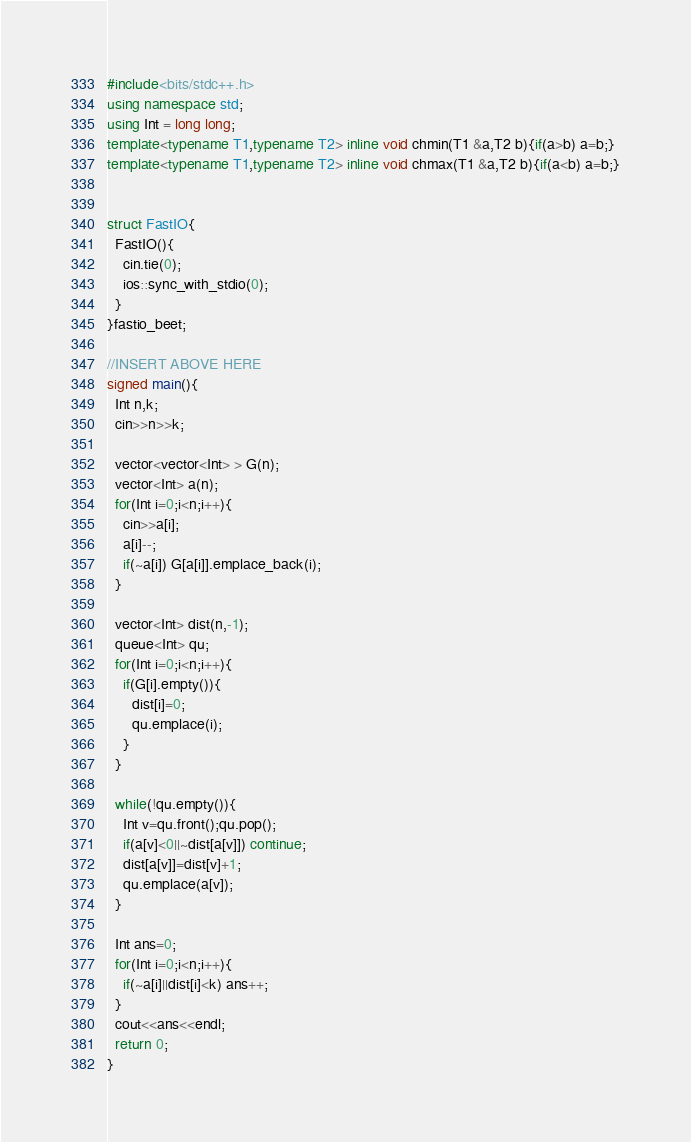<code> <loc_0><loc_0><loc_500><loc_500><_C++_>#include<bits/stdc++.h>
using namespace std;
using Int = long long;
template<typename T1,typename T2> inline void chmin(T1 &a,T2 b){if(a>b) a=b;}
template<typename T1,typename T2> inline void chmax(T1 &a,T2 b){if(a<b) a=b;}


struct FastIO{
  FastIO(){
    cin.tie(0);
    ios::sync_with_stdio(0);
  }
}fastio_beet;

//INSERT ABOVE HERE
signed main(){
  Int n,k;
  cin>>n>>k;
  
  vector<vector<Int> > G(n);
  vector<Int> a(n);
  for(Int i=0;i<n;i++){
    cin>>a[i];
    a[i]--;
    if(~a[i]) G[a[i]].emplace_back(i);
  }

  vector<Int> dist(n,-1);
  queue<Int> qu;
  for(Int i=0;i<n;i++){
    if(G[i].empty()){
      dist[i]=0;
      qu.emplace(i);
    }
  }
  
  while(!qu.empty()){
    Int v=qu.front();qu.pop();
    if(a[v]<0||~dist[a[v]]) continue;
    dist[a[v]]=dist[v]+1;
    qu.emplace(a[v]);
  }
  
  Int ans=0;
  for(Int i=0;i<n;i++){
    if(~a[i]||dist[i]<k) ans++;    
  } 
  cout<<ans<<endl;
  return 0;
}

</code> 